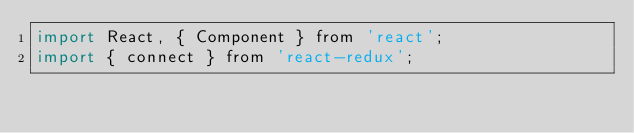Convert code to text. <code><loc_0><loc_0><loc_500><loc_500><_JavaScript_>import React, { Component } from 'react';
import { connect } from 'react-redux';</code> 